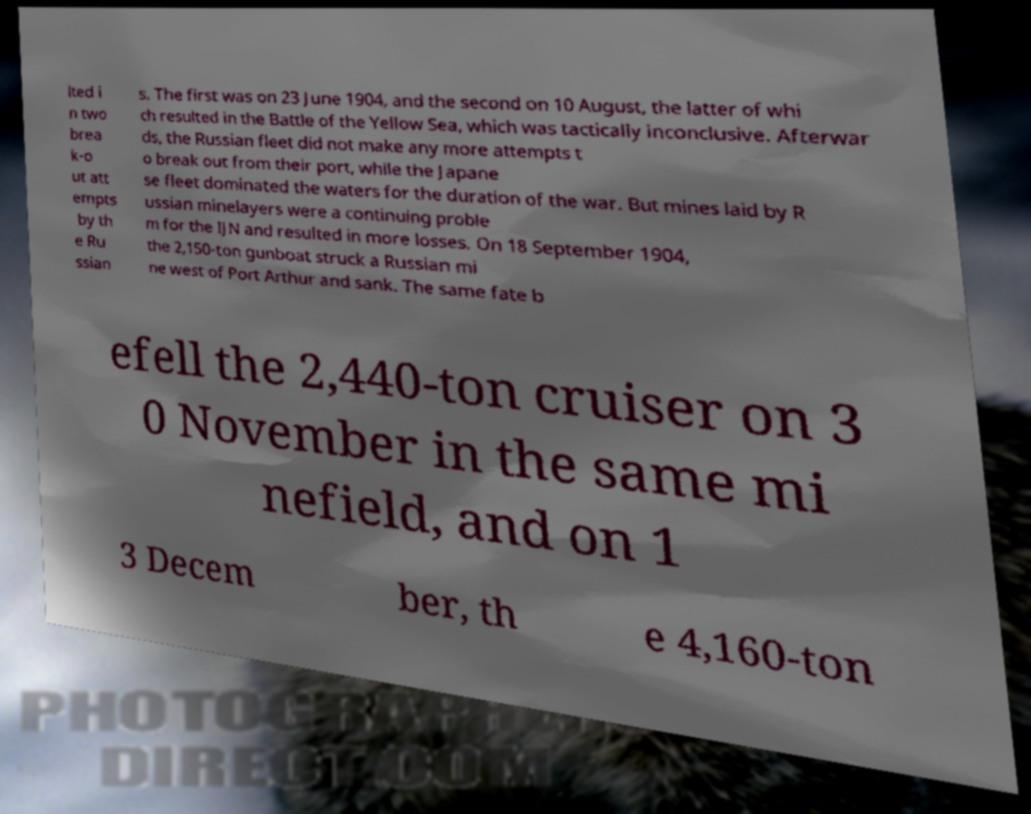There's text embedded in this image that I need extracted. Can you transcribe it verbatim? lted i n two brea k-o ut att empts by th e Ru ssian s. The first was on 23 June 1904, and the second on 10 August, the latter of whi ch resulted in the Battle of the Yellow Sea, which was tactically inconclusive. Afterwar ds, the Russian fleet did not make any more attempts t o break out from their port, while the Japane se fleet dominated the waters for the duration of the war. But mines laid by R ussian minelayers were a continuing proble m for the IJN and resulted in more losses. On 18 September 1904, the 2,150-ton gunboat struck a Russian mi ne west of Port Arthur and sank. The same fate b efell the 2,440-ton cruiser on 3 0 November in the same mi nefield, and on 1 3 Decem ber, th e 4,160-ton 